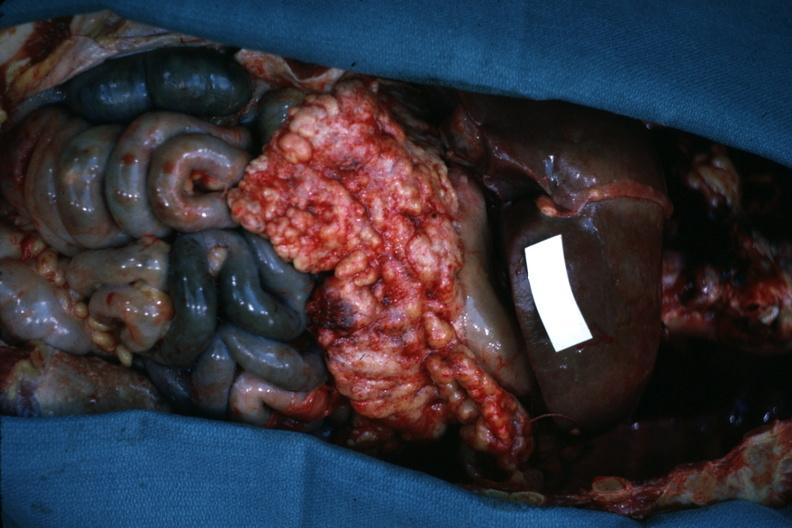does this image show opened abdominal cavity with massive tumor in omentum none apparent in liver nor over peritoneal surfaces gut is ischemic?
Answer the question using a single word or phrase. Yes 